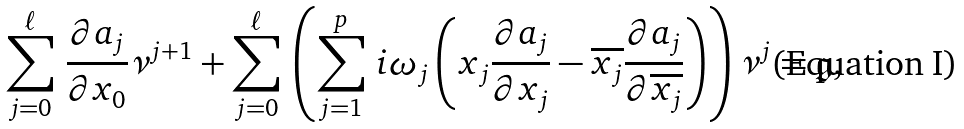<formula> <loc_0><loc_0><loc_500><loc_500>\sum _ { j = 0 } ^ { \ell } \, \frac { \partial a _ { j } } { \partial x _ { 0 } } \nu ^ { j + 1 } + \sum _ { j = 0 } ^ { \ell } \, \left ( \sum _ { j = 1 } ^ { p } \, i \omega _ { j } \left ( x _ { j } \frac { \partial a _ { j } } { \partial { x _ { j } } } - \overline { x _ { j } } \frac { \partial a _ { j } } { \partial { \overline { x _ { j } } } } \right ) \right ) \nu ^ { j } = \mathfrak { g } ,</formula> 